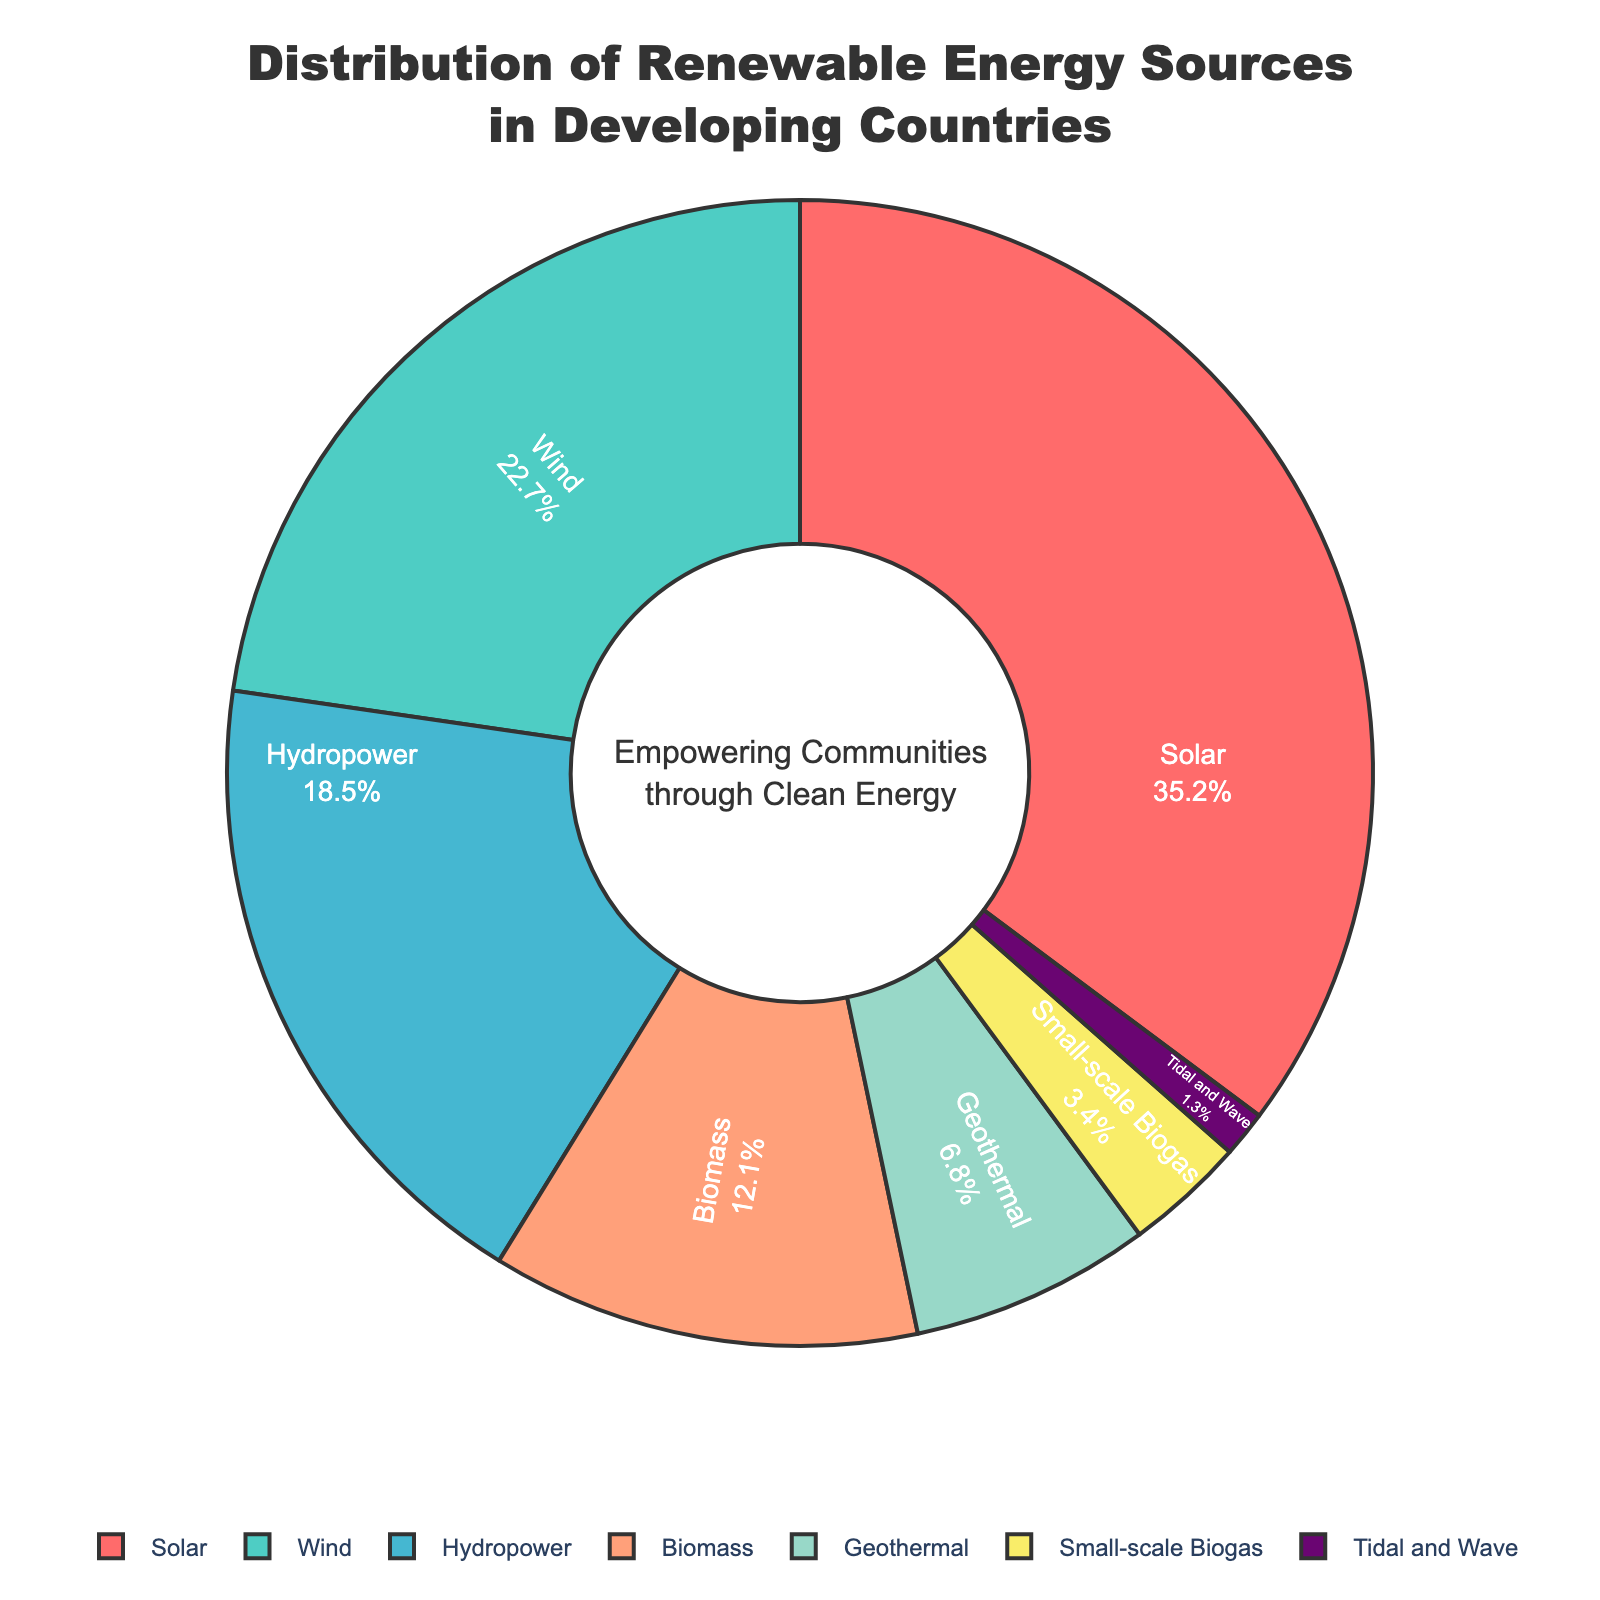What percentage of renewable energy in developing countries comes from Solar and Wind combined? To find the combined percentage of Solar and Wind, we add the two values together: 35.2% (Solar) + 22.7% (Wind) = 57.9%.
Answer: 57.9% Which renewable energy source contributes the least to the total percentage? By looking at the chart, the smallest segment represents Tidal and Wave energy, which has the smallest percentage of 1.3%.
Answer: Tidal and Wave Is the percentage of Hydropower greater than the total of Geothermal and Small-scale Biogas combined? First, sum Geothermal and Small-scale Biogas: 6.8% (Geothermal) + 3.4% (Small-scale Biogas) = 10.2%. Then, compare it to Hydropower which is 18.5%. Since 18.5% > 10.2%, yes, Hydropower is greater.
Answer: Yes How much larger is the percentage of Solar energy compared to Biomass? For Solar: 35.2%. For Biomass: 12.1%. The difference is 35.2% - 12.1% = 23.1%.
Answer: 23.1% What proportion of the total renewable energy sources is made up of Biomass and Hydropower? The sum of Biomass and Hydropower is 12.1% + 18.5% = 30.6%.
Answer: 30.6% With respect to visual representation, what color is used to represent Wind energy? The Wind energy segment in the pie chart is depicted using a green color.
Answer: Green Is the collective contribution of Small-scale Biogas and Tidal and Wave greater than Geothermal? Sum Small-scale Biogas and Tidal and Wave: 3.4% + 1.3% = 4.7%. Compare this to Geothermal, which is 6.8%. Since 4.7% < 6.8%, the collective contribution is not greater.
Answer: No Does the segment representing Solar energy occupy more than one-third of the pie chart? One-third of the pie chart is approximately 33.33%. Solar energy's percentage is 35.2%, which is greater than 33.33%.
Answer: Yes 